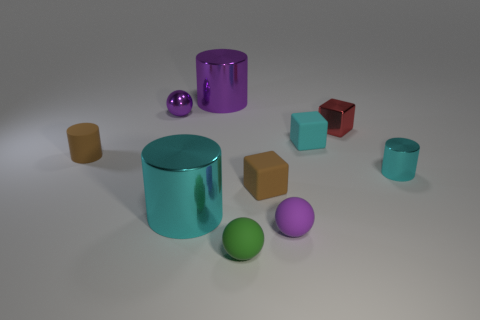How many small cyan things are left of the big thing behind the brown cylinder?
Your answer should be very brief. 0. There is a cyan matte cube; are there any spheres on the right side of it?
Offer a very short reply. No. Is the shape of the tiny purple object that is to the left of the brown rubber block the same as  the green matte thing?
Your answer should be very brief. Yes. There is a large thing that is the same color as the shiny ball; what is its material?
Keep it short and to the point. Metal. What number of big metallic cylinders have the same color as the metal sphere?
Make the answer very short. 1. There is a big object behind the cyan cylinder that is on the left side of the tiny green rubber object; what shape is it?
Ensure brevity in your answer.  Cylinder. Is there a purple metal object of the same shape as the big cyan thing?
Make the answer very short. Yes. Does the rubber cylinder have the same color as the matte block in front of the brown cylinder?
Your answer should be compact. Yes. There is a metal object that is the same color as the tiny metallic ball; what size is it?
Provide a succinct answer. Large. Is there a rubber cube that has the same size as the red metallic cube?
Your response must be concise. Yes. 